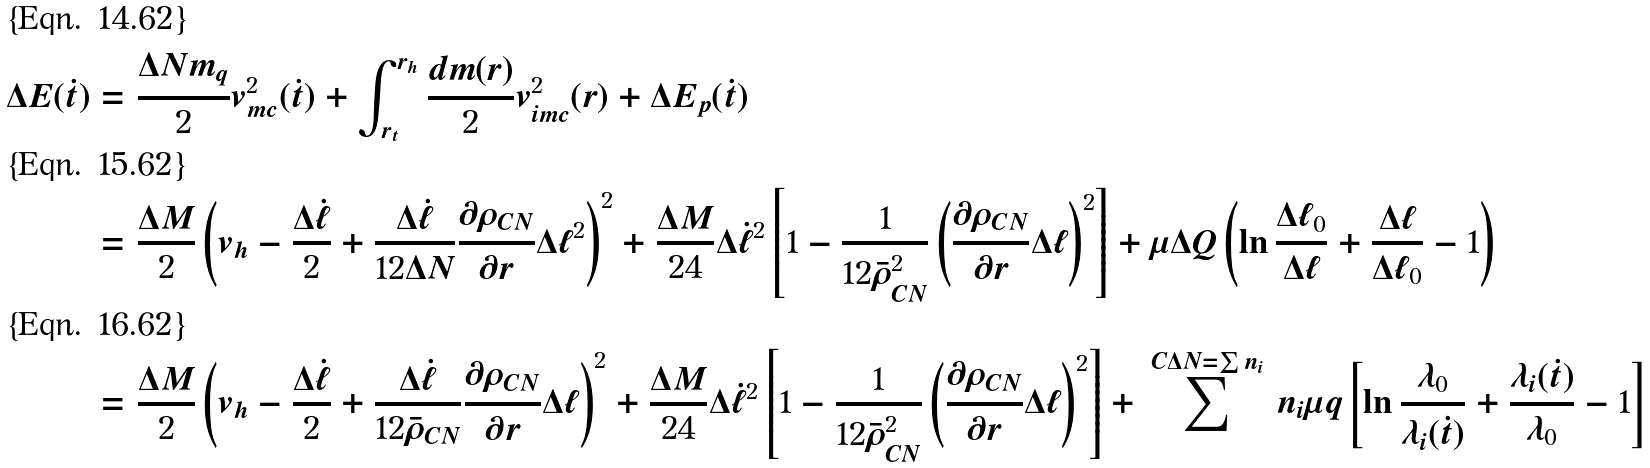Convert formula to latex. <formula><loc_0><loc_0><loc_500><loc_500>\Delta E ( \dot { t } ) & = \frac { \Delta N m _ { q } } { 2 } v _ { m c } ^ { 2 } ( \dot { t } ) + \int _ { r _ { t } } ^ { r _ { h } } \frac { d m ( r ) } { 2 } v _ { i m c } ^ { 2 } ( r ) + \Delta E _ { p } ( \dot { t } ) \\ & = \frac { \Delta M } { 2 } \left ( v _ { h } - \frac { \Delta \dot { \ell } } { 2 } + \frac { \Delta \dot { \ell } } { 1 2 \Delta N } \frac { \partial \rho _ { C N } } { \partial r } \Delta \ell ^ { 2 } \right ) ^ { 2 } + \frac { \Delta M } { 2 4 } \Delta \dot { \ell } ^ { 2 } \left [ 1 - \frac { 1 } { 1 2 \bar { \rho } _ { C N } ^ { 2 } } \left ( \frac { \partial \rho _ { C N } } { \partial r } \Delta \ell \right ) ^ { 2 } \right ] + \mu \Delta Q \left ( \ln \frac { \Delta \ell _ { 0 } } { \Delta \ell } + \frac { \Delta \ell } { \Delta \ell _ { 0 } } - 1 \right ) \\ & = \frac { \Delta M } { 2 } \left ( v _ { h } - \frac { \Delta \dot { \ell } } { 2 } + \frac { \Delta \dot { \ell } } { 1 2 \bar { \rho } _ { C N } } \frac { \partial \rho _ { C N } } { \partial r } \Delta \ell \right ) ^ { 2 } + \frac { \Delta M } { 2 4 } \Delta \dot { \ell } ^ { 2 } \left [ 1 - \frac { 1 } { 1 2 \bar { \rho } _ { C N } ^ { 2 } } \left ( \frac { \partial \rho _ { C N } } { \partial r } \Delta \ell \right ) ^ { 2 } \right ] + \, \sum ^ { C { \Delta N = \sum n _ { i } } } \, n _ { i } \mu q \left [ \ln \frac { \lambda _ { 0 } } { \lambda _ { i } ( \dot { t } ) } + \frac { \lambda _ { i } ( \dot { t } ) } { \lambda _ { 0 } } - 1 \right ]</formula> 